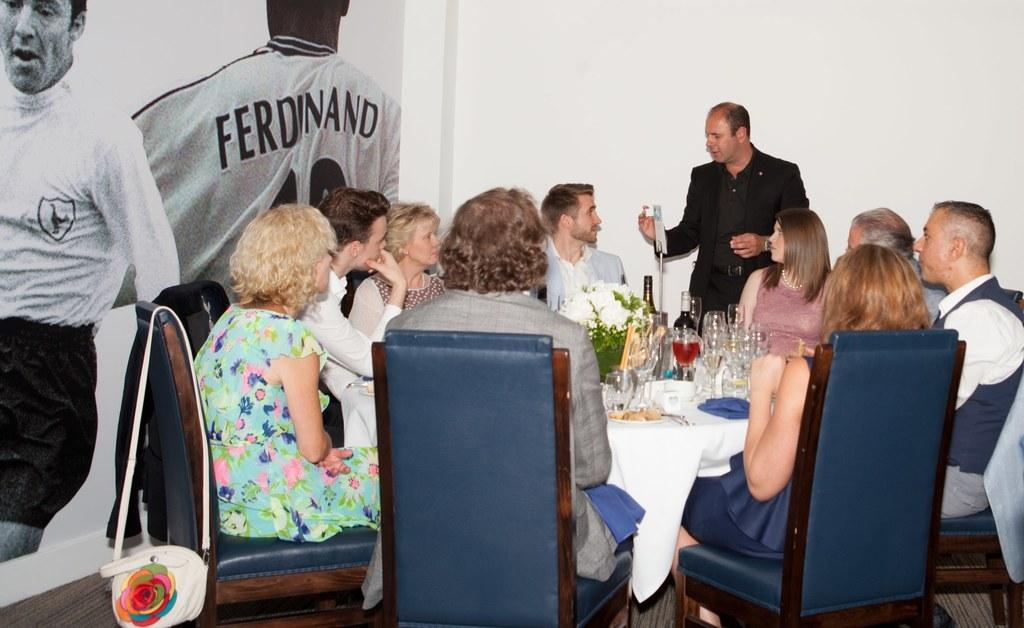How many people are in the image? There is a group of people in the image. What are the people doing in the image? The people are sitting on chairs. Where are the chairs located in relation to the table? The chairs are in front of a table. What can be seen on the table in the image? There are glasses, a glass bottle, and other objects on the table. What type of oatmeal is being served for dinner in the image? There is no oatmeal or dinner being served in the image; it features a group of people sitting in front of a table with glasses, a glass bottle, and other objects. How many sisters are present in the image? There is no mention of sisters in the image; it only shows a group of people sitting in front of a table. 